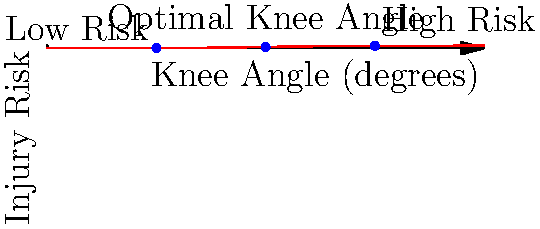Based on the injury risk curve for knee angle during skateboarding maneuvers, at what approximate knee angle (in degrees) does the injury risk reach 50%? To determine the knee angle at which injury risk reaches 50%, we need to analyze the given graph:

1. The y-axis represents injury risk, ranging from 0 to 1 (0% to 100%).
2. The x-axis represents knee angle in degrees, ranging from 0° to 180°.
3. The red curve shows the relationship between knee angle and injury risk.
4. We need to find the point on the curve where the y-value (injury risk) is 0.5 (50%).

Looking at the graph:

5. We can see a blue dot labeled "Optimal Knee Angle" at the midpoint of the curve.
6. This point appears to be at (90, 0.5) on the graph.
7. The 0.5 on the y-axis corresponds to 50% injury risk.

Therefore, the knee angle at which injury risk reaches 50% is approximately 90 degrees.

This makes sense biomechanically, as extreme knee angles (either too bent or too straight) increase injury risk, while a moderate bend around 90 degrees provides optimal stability and shock absorption during skateboarding maneuvers.
Answer: 90 degrees 